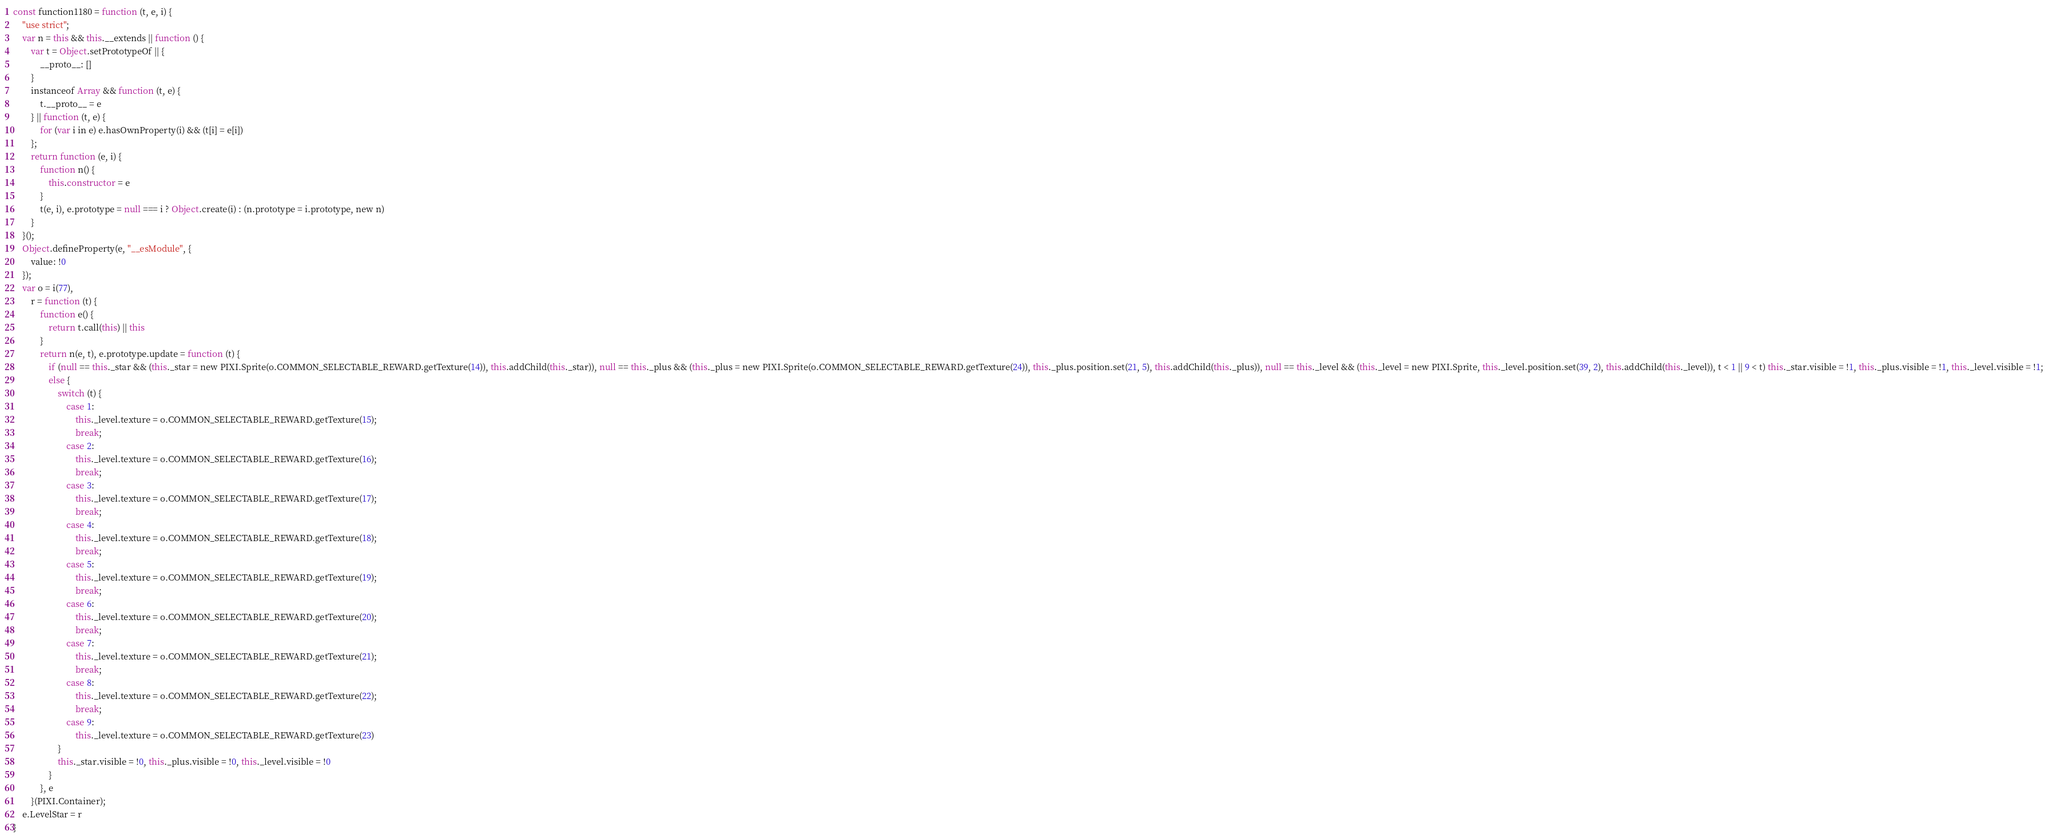<code> <loc_0><loc_0><loc_500><loc_500><_JavaScript_>const function1180 = function (t, e, i) {
    "use strict";
    var n = this && this.__extends || function () {
        var t = Object.setPrototypeOf || {
            __proto__: []
        }
        instanceof Array && function (t, e) {
            t.__proto__ = e
        } || function (t, e) {
            for (var i in e) e.hasOwnProperty(i) && (t[i] = e[i])
        };
        return function (e, i) {
            function n() {
                this.constructor = e
            }
            t(e, i), e.prototype = null === i ? Object.create(i) : (n.prototype = i.prototype, new n)
        }
    }();
    Object.defineProperty(e, "__esModule", {
        value: !0
    });
    var o = i(77),
        r = function (t) {
            function e() {
                return t.call(this) || this
            }
            return n(e, t), e.prototype.update = function (t) {
                if (null == this._star && (this._star = new PIXI.Sprite(o.COMMON_SELECTABLE_REWARD.getTexture(14)), this.addChild(this._star)), null == this._plus && (this._plus = new PIXI.Sprite(o.COMMON_SELECTABLE_REWARD.getTexture(24)), this._plus.position.set(21, 5), this.addChild(this._plus)), null == this._level && (this._level = new PIXI.Sprite, this._level.position.set(39, 2), this.addChild(this._level)), t < 1 || 9 < t) this._star.visible = !1, this._plus.visible = !1, this._level.visible = !1;
                else {
                    switch (t) {
                        case 1:
                            this._level.texture = o.COMMON_SELECTABLE_REWARD.getTexture(15);
                            break;
                        case 2:
                            this._level.texture = o.COMMON_SELECTABLE_REWARD.getTexture(16);
                            break;
                        case 3:
                            this._level.texture = o.COMMON_SELECTABLE_REWARD.getTexture(17);
                            break;
                        case 4:
                            this._level.texture = o.COMMON_SELECTABLE_REWARD.getTexture(18);
                            break;
                        case 5:
                            this._level.texture = o.COMMON_SELECTABLE_REWARD.getTexture(19);
                            break;
                        case 6:
                            this._level.texture = o.COMMON_SELECTABLE_REWARD.getTexture(20);
                            break;
                        case 7:
                            this._level.texture = o.COMMON_SELECTABLE_REWARD.getTexture(21);
                            break;
                        case 8:
                            this._level.texture = o.COMMON_SELECTABLE_REWARD.getTexture(22);
                            break;
                        case 9:
                            this._level.texture = o.COMMON_SELECTABLE_REWARD.getTexture(23)
                    }
                    this._star.visible = !0, this._plus.visible = !0, this._level.visible = !0
                }
            }, e
        }(PIXI.Container);
    e.LevelStar = r
}</code> 